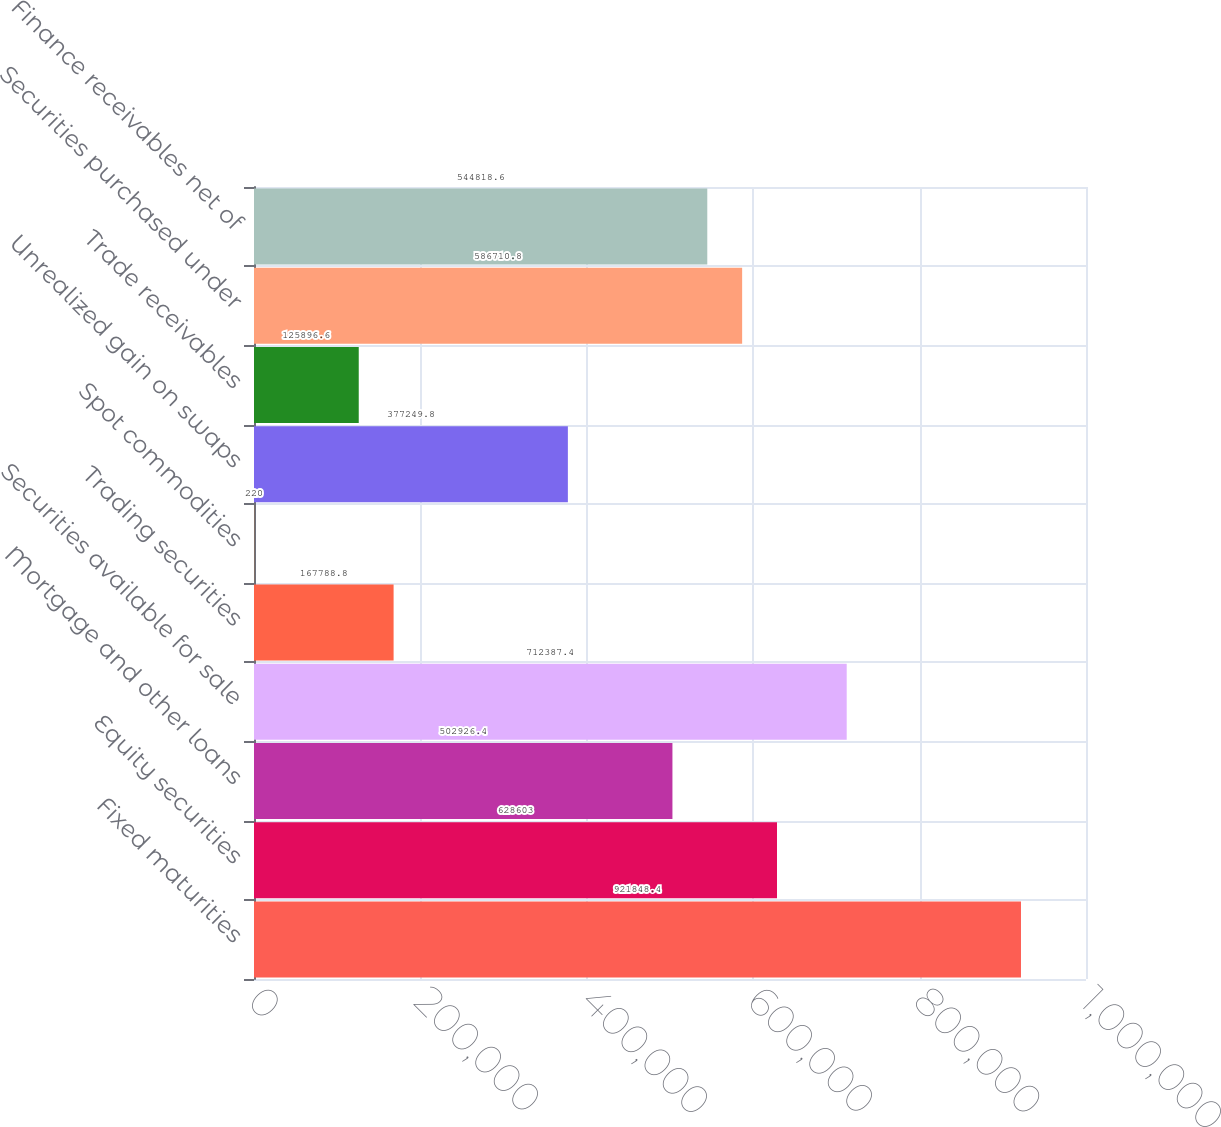<chart> <loc_0><loc_0><loc_500><loc_500><bar_chart><fcel>Fixed maturities<fcel>Equity securities<fcel>Mortgage and other loans<fcel>Securities available for sale<fcel>Trading securities<fcel>Spot commodities<fcel>Unrealized gain on swaps<fcel>Trade receivables<fcel>Securities purchased under<fcel>Finance receivables net of<nl><fcel>921848<fcel>628603<fcel>502926<fcel>712387<fcel>167789<fcel>220<fcel>377250<fcel>125897<fcel>586711<fcel>544819<nl></chart> 